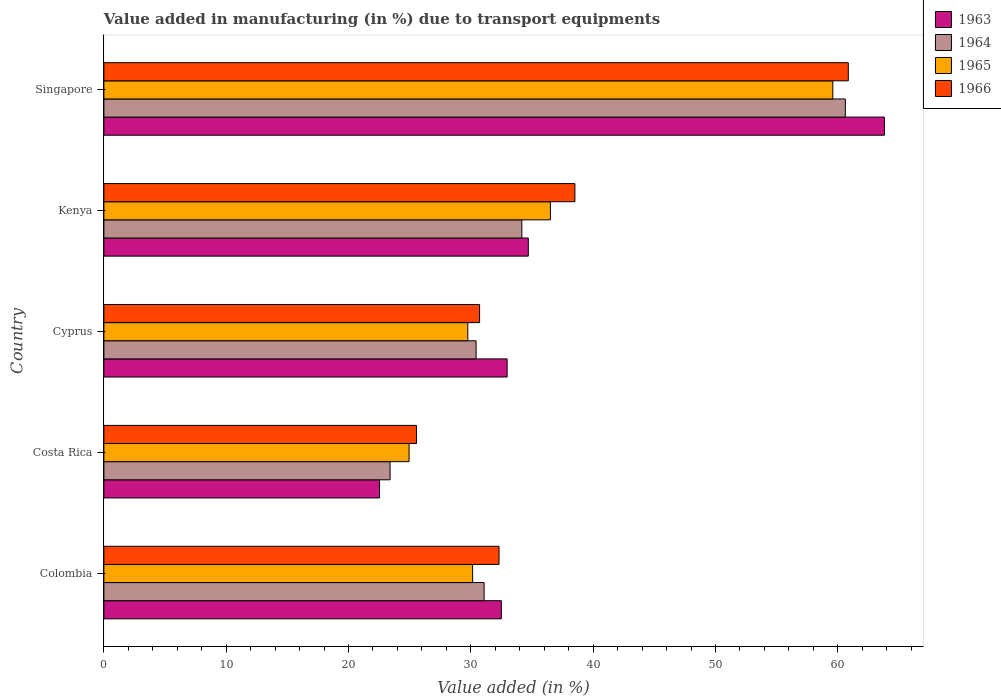How many different coloured bars are there?
Offer a very short reply. 4. How many groups of bars are there?
Make the answer very short. 5. Are the number of bars per tick equal to the number of legend labels?
Keep it short and to the point. Yes. In how many cases, is the number of bars for a given country not equal to the number of legend labels?
Your response must be concise. 0. What is the percentage of value added in manufacturing due to transport equipments in 1963 in Costa Rica?
Ensure brevity in your answer.  22.53. Across all countries, what is the maximum percentage of value added in manufacturing due to transport equipments in 1964?
Ensure brevity in your answer.  60.62. Across all countries, what is the minimum percentage of value added in manufacturing due to transport equipments in 1963?
Give a very brief answer. 22.53. In which country was the percentage of value added in manufacturing due to transport equipments in 1964 maximum?
Keep it short and to the point. Singapore. In which country was the percentage of value added in manufacturing due to transport equipments in 1965 minimum?
Give a very brief answer. Costa Rica. What is the total percentage of value added in manufacturing due to transport equipments in 1965 in the graph?
Keep it short and to the point. 180.94. What is the difference between the percentage of value added in manufacturing due to transport equipments in 1966 in Costa Rica and that in Cyprus?
Your answer should be very brief. -5.16. What is the difference between the percentage of value added in manufacturing due to transport equipments in 1965 in Cyprus and the percentage of value added in manufacturing due to transport equipments in 1964 in Singapore?
Ensure brevity in your answer.  -30.86. What is the average percentage of value added in manufacturing due to transport equipments in 1964 per country?
Provide a short and direct response. 35.94. What is the difference between the percentage of value added in manufacturing due to transport equipments in 1964 and percentage of value added in manufacturing due to transport equipments in 1965 in Kenya?
Make the answer very short. -2.33. In how many countries, is the percentage of value added in manufacturing due to transport equipments in 1965 greater than 32 %?
Offer a terse response. 2. What is the ratio of the percentage of value added in manufacturing due to transport equipments in 1965 in Cyprus to that in Kenya?
Ensure brevity in your answer.  0.82. What is the difference between the highest and the second highest percentage of value added in manufacturing due to transport equipments in 1965?
Your answer should be very brief. 23.09. What is the difference between the highest and the lowest percentage of value added in manufacturing due to transport equipments in 1963?
Offer a terse response. 41.28. In how many countries, is the percentage of value added in manufacturing due to transport equipments in 1966 greater than the average percentage of value added in manufacturing due to transport equipments in 1966 taken over all countries?
Your answer should be very brief. 2. Is the sum of the percentage of value added in manufacturing due to transport equipments in 1963 in Cyprus and Singapore greater than the maximum percentage of value added in manufacturing due to transport equipments in 1965 across all countries?
Give a very brief answer. Yes. What does the 4th bar from the top in Costa Rica represents?
Keep it short and to the point. 1963. What does the 3rd bar from the bottom in Cyprus represents?
Your response must be concise. 1965. Is it the case that in every country, the sum of the percentage of value added in manufacturing due to transport equipments in 1964 and percentage of value added in manufacturing due to transport equipments in 1965 is greater than the percentage of value added in manufacturing due to transport equipments in 1963?
Provide a short and direct response. Yes. How many bars are there?
Give a very brief answer. 20. Are the values on the major ticks of X-axis written in scientific E-notation?
Your response must be concise. No. Does the graph contain any zero values?
Your answer should be compact. No. How are the legend labels stacked?
Give a very brief answer. Vertical. What is the title of the graph?
Provide a short and direct response. Value added in manufacturing (in %) due to transport equipments. What is the label or title of the X-axis?
Ensure brevity in your answer.  Value added (in %). What is the Value added (in %) in 1963 in Colombia?
Give a very brief answer. 32.49. What is the Value added (in %) in 1964 in Colombia?
Make the answer very short. 31.09. What is the Value added (in %) in 1965 in Colombia?
Your answer should be very brief. 30.15. What is the Value added (in %) of 1966 in Colombia?
Offer a very short reply. 32.3. What is the Value added (in %) of 1963 in Costa Rica?
Your answer should be very brief. 22.53. What is the Value added (in %) in 1964 in Costa Rica?
Ensure brevity in your answer.  23.4. What is the Value added (in %) of 1965 in Costa Rica?
Ensure brevity in your answer.  24.95. What is the Value added (in %) of 1966 in Costa Rica?
Give a very brief answer. 25.56. What is the Value added (in %) of 1963 in Cyprus?
Ensure brevity in your answer.  32.97. What is the Value added (in %) of 1964 in Cyprus?
Keep it short and to the point. 30.43. What is the Value added (in %) of 1965 in Cyprus?
Offer a very short reply. 29.75. What is the Value added (in %) of 1966 in Cyprus?
Offer a terse response. 30.72. What is the Value added (in %) of 1963 in Kenya?
Provide a succinct answer. 34.7. What is the Value added (in %) of 1964 in Kenya?
Provide a succinct answer. 34.17. What is the Value added (in %) of 1965 in Kenya?
Make the answer very short. 36.5. What is the Value added (in %) in 1966 in Kenya?
Keep it short and to the point. 38.51. What is the Value added (in %) in 1963 in Singapore?
Your response must be concise. 63.81. What is the Value added (in %) in 1964 in Singapore?
Ensure brevity in your answer.  60.62. What is the Value added (in %) in 1965 in Singapore?
Your response must be concise. 59.59. What is the Value added (in %) of 1966 in Singapore?
Offer a terse response. 60.86. Across all countries, what is the maximum Value added (in %) of 1963?
Provide a succinct answer. 63.81. Across all countries, what is the maximum Value added (in %) of 1964?
Offer a very short reply. 60.62. Across all countries, what is the maximum Value added (in %) in 1965?
Your answer should be very brief. 59.59. Across all countries, what is the maximum Value added (in %) of 1966?
Give a very brief answer. 60.86. Across all countries, what is the minimum Value added (in %) of 1963?
Give a very brief answer. 22.53. Across all countries, what is the minimum Value added (in %) of 1964?
Ensure brevity in your answer.  23.4. Across all countries, what is the minimum Value added (in %) in 1965?
Ensure brevity in your answer.  24.95. Across all countries, what is the minimum Value added (in %) in 1966?
Provide a succinct answer. 25.56. What is the total Value added (in %) in 1963 in the graph?
Your response must be concise. 186.5. What is the total Value added (in %) in 1964 in the graph?
Give a very brief answer. 179.7. What is the total Value added (in %) in 1965 in the graph?
Offer a very short reply. 180.94. What is the total Value added (in %) in 1966 in the graph?
Keep it short and to the point. 187.95. What is the difference between the Value added (in %) of 1963 in Colombia and that in Costa Rica?
Keep it short and to the point. 9.96. What is the difference between the Value added (in %) of 1964 in Colombia and that in Costa Rica?
Offer a terse response. 7.69. What is the difference between the Value added (in %) of 1965 in Colombia and that in Costa Rica?
Your answer should be very brief. 5.2. What is the difference between the Value added (in %) of 1966 in Colombia and that in Costa Rica?
Ensure brevity in your answer.  6.74. What is the difference between the Value added (in %) of 1963 in Colombia and that in Cyprus?
Provide a short and direct response. -0.47. What is the difference between the Value added (in %) in 1964 in Colombia and that in Cyprus?
Provide a short and direct response. 0.66. What is the difference between the Value added (in %) in 1965 in Colombia and that in Cyprus?
Offer a terse response. 0.39. What is the difference between the Value added (in %) of 1966 in Colombia and that in Cyprus?
Offer a terse response. 1.59. What is the difference between the Value added (in %) of 1963 in Colombia and that in Kenya?
Keep it short and to the point. -2.21. What is the difference between the Value added (in %) in 1964 in Colombia and that in Kenya?
Give a very brief answer. -3.08. What is the difference between the Value added (in %) in 1965 in Colombia and that in Kenya?
Offer a very short reply. -6.36. What is the difference between the Value added (in %) of 1966 in Colombia and that in Kenya?
Your answer should be compact. -6.2. What is the difference between the Value added (in %) in 1963 in Colombia and that in Singapore?
Your answer should be very brief. -31.32. What is the difference between the Value added (in %) in 1964 in Colombia and that in Singapore?
Ensure brevity in your answer.  -29.53. What is the difference between the Value added (in %) of 1965 in Colombia and that in Singapore?
Your answer should be compact. -29.45. What is the difference between the Value added (in %) of 1966 in Colombia and that in Singapore?
Make the answer very short. -28.56. What is the difference between the Value added (in %) in 1963 in Costa Rica and that in Cyprus?
Provide a succinct answer. -10.43. What is the difference between the Value added (in %) in 1964 in Costa Rica and that in Cyprus?
Your answer should be compact. -7.03. What is the difference between the Value added (in %) in 1965 in Costa Rica and that in Cyprus?
Offer a terse response. -4.8. What is the difference between the Value added (in %) in 1966 in Costa Rica and that in Cyprus?
Ensure brevity in your answer.  -5.16. What is the difference between the Value added (in %) in 1963 in Costa Rica and that in Kenya?
Give a very brief answer. -12.17. What is the difference between the Value added (in %) of 1964 in Costa Rica and that in Kenya?
Keep it short and to the point. -10.77. What is the difference between the Value added (in %) in 1965 in Costa Rica and that in Kenya?
Ensure brevity in your answer.  -11.55. What is the difference between the Value added (in %) in 1966 in Costa Rica and that in Kenya?
Ensure brevity in your answer.  -12.95. What is the difference between the Value added (in %) in 1963 in Costa Rica and that in Singapore?
Ensure brevity in your answer.  -41.28. What is the difference between the Value added (in %) of 1964 in Costa Rica and that in Singapore?
Offer a very short reply. -37.22. What is the difference between the Value added (in %) in 1965 in Costa Rica and that in Singapore?
Provide a short and direct response. -34.64. What is the difference between the Value added (in %) in 1966 in Costa Rica and that in Singapore?
Keep it short and to the point. -35.3. What is the difference between the Value added (in %) in 1963 in Cyprus and that in Kenya?
Make the answer very short. -1.73. What is the difference between the Value added (in %) of 1964 in Cyprus and that in Kenya?
Make the answer very short. -3.74. What is the difference between the Value added (in %) in 1965 in Cyprus and that in Kenya?
Keep it short and to the point. -6.75. What is the difference between the Value added (in %) of 1966 in Cyprus and that in Kenya?
Provide a short and direct response. -7.79. What is the difference between the Value added (in %) of 1963 in Cyprus and that in Singapore?
Ensure brevity in your answer.  -30.84. What is the difference between the Value added (in %) in 1964 in Cyprus and that in Singapore?
Keep it short and to the point. -30.19. What is the difference between the Value added (in %) in 1965 in Cyprus and that in Singapore?
Make the answer very short. -29.84. What is the difference between the Value added (in %) in 1966 in Cyprus and that in Singapore?
Your answer should be compact. -30.14. What is the difference between the Value added (in %) of 1963 in Kenya and that in Singapore?
Your answer should be very brief. -29.11. What is the difference between the Value added (in %) of 1964 in Kenya and that in Singapore?
Provide a succinct answer. -26.45. What is the difference between the Value added (in %) in 1965 in Kenya and that in Singapore?
Offer a very short reply. -23.09. What is the difference between the Value added (in %) in 1966 in Kenya and that in Singapore?
Offer a very short reply. -22.35. What is the difference between the Value added (in %) of 1963 in Colombia and the Value added (in %) of 1964 in Costa Rica?
Provide a short and direct response. 9.1. What is the difference between the Value added (in %) of 1963 in Colombia and the Value added (in %) of 1965 in Costa Rica?
Your answer should be very brief. 7.54. What is the difference between the Value added (in %) of 1963 in Colombia and the Value added (in %) of 1966 in Costa Rica?
Give a very brief answer. 6.93. What is the difference between the Value added (in %) of 1964 in Colombia and the Value added (in %) of 1965 in Costa Rica?
Provide a short and direct response. 6.14. What is the difference between the Value added (in %) in 1964 in Colombia and the Value added (in %) in 1966 in Costa Rica?
Your answer should be compact. 5.53. What is the difference between the Value added (in %) in 1965 in Colombia and the Value added (in %) in 1966 in Costa Rica?
Give a very brief answer. 4.59. What is the difference between the Value added (in %) of 1963 in Colombia and the Value added (in %) of 1964 in Cyprus?
Provide a succinct answer. 2.06. What is the difference between the Value added (in %) of 1963 in Colombia and the Value added (in %) of 1965 in Cyprus?
Provide a short and direct response. 2.74. What is the difference between the Value added (in %) of 1963 in Colombia and the Value added (in %) of 1966 in Cyprus?
Make the answer very short. 1.78. What is the difference between the Value added (in %) in 1964 in Colombia and the Value added (in %) in 1965 in Cyprus?
Ensure brevity in your answer.  1.33. What is the difference between the Value added (in %) in 1964 in Colombia and the Value added (in %) in 1966 in Cyprus?
Give a very brief answer. 0.37. What is the difference between the Value added (in %) in 1965 in Colombia and the Value added (in %) in 1966 in Cyprus?
Your answer should be very brief. -0.57. What is the difference between the Value added (in %) in 1963 in Colombia and the Value added (in %) in 1964 in Kenya?
Offer a very short reply. -1.68. What is the difference between the Value added (in %) of 1963 in Colombia and the Value added (in %) of 1965 in Kenya?
Your response must be concise. -4.01. What is the difference between the Value added (in %) of 1963 in Colombia and the Value added (in %) of 1966 in Kenya?
Ensure brevity in your answer.  -6.01. What is the difference between the Value added (in %) in 1964 in Colombia and the Value added (in %) in 1965 in Kenya?
Provide a short and direct response. -5.42. What is the difference between the Value added (in %) of 1964 in Colombia and the Value added (in %) of 1966 in Kenya?
Offer a terse response. -7.42. What is the difference between the Value added (in %) of 1965 in Colombia and the Value added (in %) of 1966 in Kenya?
Keep it short and to the point. -8.36. What is the difference between the Value added (in %) of 1963 in Colombia and the Value added (in %) of 1964 in Singapore?
Keep it short and to the point. -28.12. What is the difference between the Value added (in %) in 1963 in Colombia and the Value added (in %) in 1965 in Singapore?
Keep it short and to the point. -27.1. What is the difference between the Value added (in %) in 1963 in Colombia and the Value added (in %) in 1966 in Singapore?
Provide a short and direct response. -28.37. What is the difference between the Value added (in %) in 1964 in Colombia and the Value added (in %) in 1965 in Singapore?
Provide a short and direct response. -28.51. What is the difference between the Value added (in %) in 1964 in Colombia and the Value added (in %) in 1966 in Singapore?
Your answer should be very brief. -29.77. What is the difference between the Value added (in %) of 1965 in Colombia and the Value added (in %) of 1966 in Singapore?
Make the answer very short. -30.71. What is the difference between the Value added (in %) in 1963 in Costa Rica and the Value added (in %) in 1964 in Cyprus?
Provide a succinct answer. -7.9. What is the difference between the Value added (in %) in 1963 in Costa Rica and the Value added (in %) in 1965 in Cyprus?
Ensure brevity in your answer.  -7.22. What is the difference between the Value added (in %) of 1963 in Costa Rica and the Value added (in %) of 1966 in Cyprus?
Offer a very short reply. -8.18. What is the difference between the Value added (in %) in 1964 in Costa Rica and the Value added (in %) in 1965 in Cyprus?
Make the answer very short. -6.36. What is the difference between the Value added (in %) of 1964 in Costa Rica and the Value added (in %) of 1966 in Cyprus?
Ensure brevity in your answer.  -7.32. What is the difference between the Value added (in %) of 1965 in Costa Rica and the Value added (in %) of 1966 in Cyprus?
Offer a very short reply. -5.77. What is the difference between the Value added (in %) of 1963 in Costa Rica and the Value added (in %) of 1964 in Kenya?
Make the answer very short. -11.64. What is the difference between the Value added (in %) in 1963 in Costa Rica and the Value added (in %) in 1965 in Kenya?
Offer a terse response. -13.97. What is the difference between the Value added (in %) of 1963 in Costa Rica and the Value added (in %) of 1966 in Kenya?
Offer a very short reply. -15.97. What is the difference between the Value added (in %) of 1964 in Costa Rica and the Value added (in %) of 1965 in Kenya?
Ensure brevity in your answer.  -13.11. What is the difference between the Value added (in %) of 1964 in Costa Rica and the Value added (in %) of 1966 in Kenya?
Make the answer very short. -15.11. What is the difference between the Value added (in %) in 1965 in Costa Rica and the Value added (in %) in 1966 in Kenya?
Give a very brief answer. -13.56. What is the difference between the Value added (in %) in 1963 in Costa Rica and the Value added (in %) in 1964 in Singapore?
Your response must be concise. -38.08. What is the difference between the Value added (in %) of 1963 in Costa Rica and the Value added (in %) of 1965 in Singapore?
Your answer should be compact. -37.06. What is the difference between the Value added (in %) of 1963 in Costa Rica and the Value added (in %) of 1966 in Singapore?
Give a very brief answer. -38.33. What is the difference between the Value added (in %) in 1964 in Costa Rica and the Value added (in %) in 1965 in Singapore?
Offer a terse response. -36.19. What is the difference between the Value added (in %) in 1964 in Costa Rica and the Value added (in %) in 1966 in Singapore?
Provide a short and direct response. -37.46. What is the difference between the Value added (in %) in 1965 in Costa Rica and the Value added (in %) in 1966 in Singapore?
Your answer should be compact. -35.91. What is the difference between the Value added (in %) of 1963 in Cyprus and the Value added (in %) of 1964 in Kenya?
Your answer should be compact. -1.2. What is the difference between the Value added (in %) of 1963 in Cyprus and the Value added (in %) of 1965 in Kenya?
Keep it short and to the point. -3.54. What is the difference between the Value added (in %) in 1963 in Cyprus and the Value added (in %) in 1966 in Kenya?
Your answer should be compact. -5.54. What is the difference between the Value added (in %) of 1964 in Cyprus and the Value added (in %) of 1965 in Kenya?
Ensure brevity in your answer.  -6.07. What is the difference between the Value added (in %) of 1964 in Cyprus and the Value added (in %) of 1966 in Kenya?
Your answer should be compact. -8.08. What is the difference between the Value added (in %) of 1965 in Cyprus and the Value added (in %) of 1966 in Kenya?
Make the answer very short. -8.75. What is the difference between the Value added (in %) in 1963 in Cyprus and the Value added (in %) in 1964 in Singapore?
Ensure brevity in your answer.  -27.65. What is the difference between the Value added (in %) of 1963 in Cyprus and the Value added (in %) of 1965 in Singapore?
Offer a terse response. -26.62. What is the difference between the Value added (in %) of 1963 in Cyprus and the Value added (in %) of 1966 in Singapore?
Provide a short and direct response. -27.89. What is the difference between the Value added (in %) in 1964 in Cyprus and the Value added (in %) in 1965 in Singapore?
Make the answer very short. -29.16. What is the difference between the Value added (in %) in 1964 in Cyprus and the Value added (in %) in 1966 in Singapore?
Ensure brevity in your answer.  -30.43. What is the difference between the Value added (in %) of 1965 in Cyprus and the Value added (in %) of 1966 in Singapore?
Make the answer very short. -31.11. What is the difference between the Value added (in %) in 1963 in Kenya and the Value added (in %) in 1964 in Singapore?
Keep it short and to the point. -25.92. What is the difference between the Value added (in %) in 1963 in Kenya and the Value added (in %) in 1965 in Singapore?
Offer a very short reply. -24.89. What is the difference between the Value added (in %) in 1963 in Kenya and the Value added (in %) in 1966 in Singapore?
Keep it short and to the point. -26.16. What is the difference between the Value added (in %) in 1964 in Kenya and the Value added (in %) in 1965 in Singapore?
Offer a very short reply. -25.42. What is the difference between the Value added (in %) of 1964 in Kenya and the Value added (in %) of 1966 in Singapore?
Offer a very short reply. -26.69. What is the difference between the Value added (in %) of 1965 in Kenya and the Value added (in %) of 1966 in Singapore?
Keep it short and to the point. -24.36. What is the average Value added (in %) of 1963 per country?
Your response must be concise. 37.3. What is the average Value added (in %) in 1964 per country?
Provide a short and direct response. 35.94. What is the average Value added (in %) in 1965 per country?
Provide a short and direct response. 36.19. What is the average Value added (in %) of 1966 per country?
Ensure brevity in your answer.  37.59. What is the difference between the Value added (in %) in 1963 and Value added (in %) in 1964 in Colombia?
Provide a succinct answer. 1.41. What is the difference between the Value added (in %) in 1963 and Value added (in %) in 1965 in Colombia?
Your answer should be compact. 2.35. What is the difference between the Value added (in %) of 1963 and Value added (in %) of 1966 in Colombia?
Your response must be concise. 0.19. What is the difference between the Value added (in %) of 1964 and Value added (in %) of 1965 in Colombia?
Your answer should be very brief. 0.94. What is the difference between the Value added (in %) in 1964 and Value added (in %) in 1966 in Colombia?
Offer a very short reply. -1.22. What is the difference between the Value added (in %) in 1965 and Value added (in %) in 1966 in Colombia?
Make the answer very short. -2.16. What is the difference between the Value added (in %) in 1963 and Value added (in %) in 1964 in Costa Rica?
Provide a short and direct response. -0.86. What is the difference between the Value added (in %) in 1963 and Value added (in %) in 1965 in Costa Rica?
Offer a terse response. -2.42. What is the difference between the Value added (in %) in 1963 and Value added (in %) in 1966 in Costa Rica?
Keep it short and to the point. -3.03. What is the difference between the Value added (in %) of 1964 and Value added (in %) of 1965 in Costa Rica?
Your answer should be very brief. -1.55. What is the difference between the Value added (in %) in 1964 and Value added (in %) in 1966 in Costa Rica?
Offer a terse response. -2.16. What is the difference between the Value added (in %) of 1965 and Value added (in %) of 1966 in Costa Rica?
Your answer should be very brief. -0.61. What is the difference between the Value added (in %) of 1963 and Value added (in %) of 1964 in Cyprus?
Keep it short and to the point. 2.54. What is the difference between the Value added (in %) of 1963 and Value added (in %) of 1965 in Cyprus?
Make the answer very short. 3.21. What is the difference between the Value added (in %) of 1963 and Value added (in %) of 1966 in Cyprus?
Offer a very short reply. 2.25. What is the difference between the Value added (in %) of 1964 and Value added (in %) of 1965 in Cyprus?
Offer a terse response. 0.68. What is the difference between the Value added (in %) of 1964 and Value added (in %) of 1966 in Cyprus?
Offer a very short reply. -0.29. What is the difference between the Value added (in %) in 1965 and Value added (in %) in 1966 in Cyprus?
Your answer should be compact. -0.96. What is the difference between the Value added (in %) of 1963 and Value added (in %) of 1964 in Kenya?
Offer a terse response. 0.53. What is the difference between the Value added (in %) in 1963 and Value added (in %) in 1965 in Kenya?
Keep it short and to the point. -1.8. What is the difference between the Value added (in %) in 1963 and Value added (in %) in 1966 in Kenya?
Provide a succinct answer. -3.81. What is the difference between the Value added (in %) in 1964 and Value added (in %) in 1965 in Kenya?
Ensure brevity in your answer.  -2.33. What is the difference between the Value added (in %) in 1964 and Value added (in %) in 1966 in Kenya?
Give a very brief answer. -4.34. What is the difference between the Value added (in %) of 1965 and Value added (in %) of 1966 in Kenya?
Ensure brevity in your answer.  -2. What is the difference between the Value added (in %) in 1963 and Value added (in %) in 1964 in Singapore?
Your answer should be very brief. 3.19. What is the difference between the Value added (in %) in 1963 and Value added (in %) in 1965 in Singapore?
Provide a succinct answer. 4.22. What is the difference between the Value added (in %) of 1963 and Value added (in %) of 1966 in Singapore?
Offer a very short reply. 2.95. What is the difference between the Value added (in %) of 1964 and Value added (in %) of 1965 in Singapore?
Ensure brevity in your answer.  1.03. What is the difference between the Value added (in %) of 1964 and Value added (in %) of 1966 in Singapore?
Your answer should be compact. -0.24. What is the difference between the Value added (in %) in 1965 and Value added (in %) in 1966 in Singapore?
Your answer should be very brief. -1.27. What is the ratio of the Value added (in %) of 1963 in Colombia to that in Costa Rica?
Offer a terse response. 1.44. What is the ratio of the Value added (in %) of 1964 in Colombia to that in Costa Rica?
Keep it short and to the point. 1.33. What is the ratio of the Value added (in %) of 1965 in Colombia to that in Costa Rica?
Provide a short and direct response. 1.21. What is the ratio of the Value added (in %) of 1966 in Colombia to that in Costa Rica?
Keep it short and to the point. 1.26. What is the ratio of the Value added (in %) of 1963 in Colombia to that in Cyprus?
Your response must be concise. 0.99. What is the ratio of the Value added (in %) in 1964 in Colombia to that in Cyprus?
Make the answer very short. 1.02. What is the ratio of the Value added (in %) in 1965 in Colombia to that in Cyprus?
Give a very brief answer. 1.01. What is the ratio of the Value added (in %) of 1966 in Colombia to that in Cyprus?
Ensure brevity in your answer.  1.05. What is the ratio of the Value added (in %) in 1963 in Colombia to that in Kenya?
Your answer should be very brief. 0.94. What is the ratio of the Value added (in %) in 1964 in Colombia to that in Kenya?
Give a very brief answer. 0.91. What is the ratio of the Value added (in %) of 1965 in Colombia to that in Kenya?
Keep it short and to the point. 0.83. What is the ratio of the Value added (in %) of 1966 in Colombia to that in Kenya?
Make the answer very short. 0.84. What is the ratio of the Value added (in %) in 1963 in Colombia to that in Singapore?
Your response must be concise. 0.51. What is the ratio of the Value added (in %) of 1964 in Colombia to that in Singapore?
Keep it short and to the point. 0.51. What is the ratio of the Value added (in %) in 1965 in Colombia to that in Singapore?
Offer a very short reply. 0.51. What is the ratio of the Value added (in %) in 1966 in Colombia to that in Singapore?
Give a very brief answer. 0.53. What is the ratio of the Value added (in %) in 1963 in Costa Rica to that in Cyprus?
Give a very brief answer. 0.68. What is the ratio of the Value added (in %) in 1964 in Costa Rica to that in Cyprus?
Offer a terse response. 0.77. What is the ratio of the Value added (in %) of 1965 in Costa Rica to that in Cyprus?
Your answer should be very brief. 0.84. What is the ratio of the Value added (in %) of 1966 in Costa Rica to that in Cyprus?
Keep it short and to the point. 0.83. What is the ratio of the Value added (in %) in 1963 in Costa Rica to that in Kenya?
Provide a short and direct response. 0.65. What is the ratio of the Value added (in %) of 1964 in Costa Rica to that in Kenya?
Keep it short and to the point. 0.68. What is the ratio of the Value added (in %) in 1965 in Costa Rica to that in Kenya?
Give a very brief answer. 0.68. What is the ratio of the Value added (in %) in 1966 in Costa Rica to that in Kenya?
Make the answer very short. 0.66. What is the ratio of the Value added (in %) in 1963 in Costa Rica to that in Singapore?
Your response must be concise. 0.35. What is the ratio of the Value added (in %) of 1964 in Costa Rica to that in Singapore?
Provide a succinct answer. 0.39. What is the ratio of the Value added (in %) of 1965 in Costa Rica to that in Singapore?
Keep it short and to the point. 0.42. What is the ratio of the Value added (in %) in 1966 in Costa Rica to that in Singapore?
Offer a very short reply. 0.42. What is the ratio of the Value added (in %) of 1963 in Cyprus to that in Kenya?
Give a very brief answer. 0.95. What is the ratio of the Value added (in %) of 1964 in Cyprus to that in Kenya?
Provide a succinct answer. 0.89. What is the ratio of the Value added (in %) of 1965 in Cyprus to that in Kenya?
Provide a succinct answer. 0.82. What is the ratio of the Value added (in %) in 1966 in Cyprus to that in Kenya?
Provide a short and direct response. 0.8. What is the ratio of the Value added (in %) in 1963 in Cyprus to that in Singapore?
Your response must be concise. 0.52. What is the ratio of the Value added (in %) in 1964 in Cyprus to that in Singapore?
Your answer should be compact. 0.5. What is the ratio of the Value added (in %) in 1965 in Cyprus to that in Singapore?
Your answer should be compact. 0.5. What is the ratio of the Value added (in %) in 1966 in Cyprus to that in Singapore?
Offer a terse response. 0.5. What is the ratio of the Value added (in %) of 1963 in Kenya to that in Singapore?
Your answer should be very brief. 0.54. What is the ratio of the Value added (in %) of 1964 in Kenya to that in Singapore?
Keep it short and to the point. 0.56. What is the ratio of the Value added (in %) of 1965 in Kenya to that in Singapore?
Ensure brevity in your answer.  0.61. What is the ratio of the Value added (in %) in 1966 in Kenya to that in Singapore?
Keep it short and to the point. 0.63. What is the difference between the highest and the second highest Value added (in %) in 1963?
Keep it short and to the point. 29.11. What is the difference between the highest and the second highest Value added (in %) in 1964?
Provide a short and direct response. 26.45. What is the difference between the highest and the second highest Value added (in %) of 1965?
Give a very brief answer. 23.09. What is the difference between the highest and the second highest Value added (in %) in 1966?
Provide a short and direct response. 22.35. What is the difference between the highest and the lowest Value added (in %) of 1963?
Provide a succinct answer. 41.28. What is the difference between the highest and the lowest Value added (in %) in 1964?
Your response must be concise. 37.22. What is the difference between the highest and the lowest Value added (in %) in 1965?
Your answer should be compact. 34.64. What is the difference between the highest and the lowest Value added (in %) in 1966?
Your answer should be compact. 35.3. 